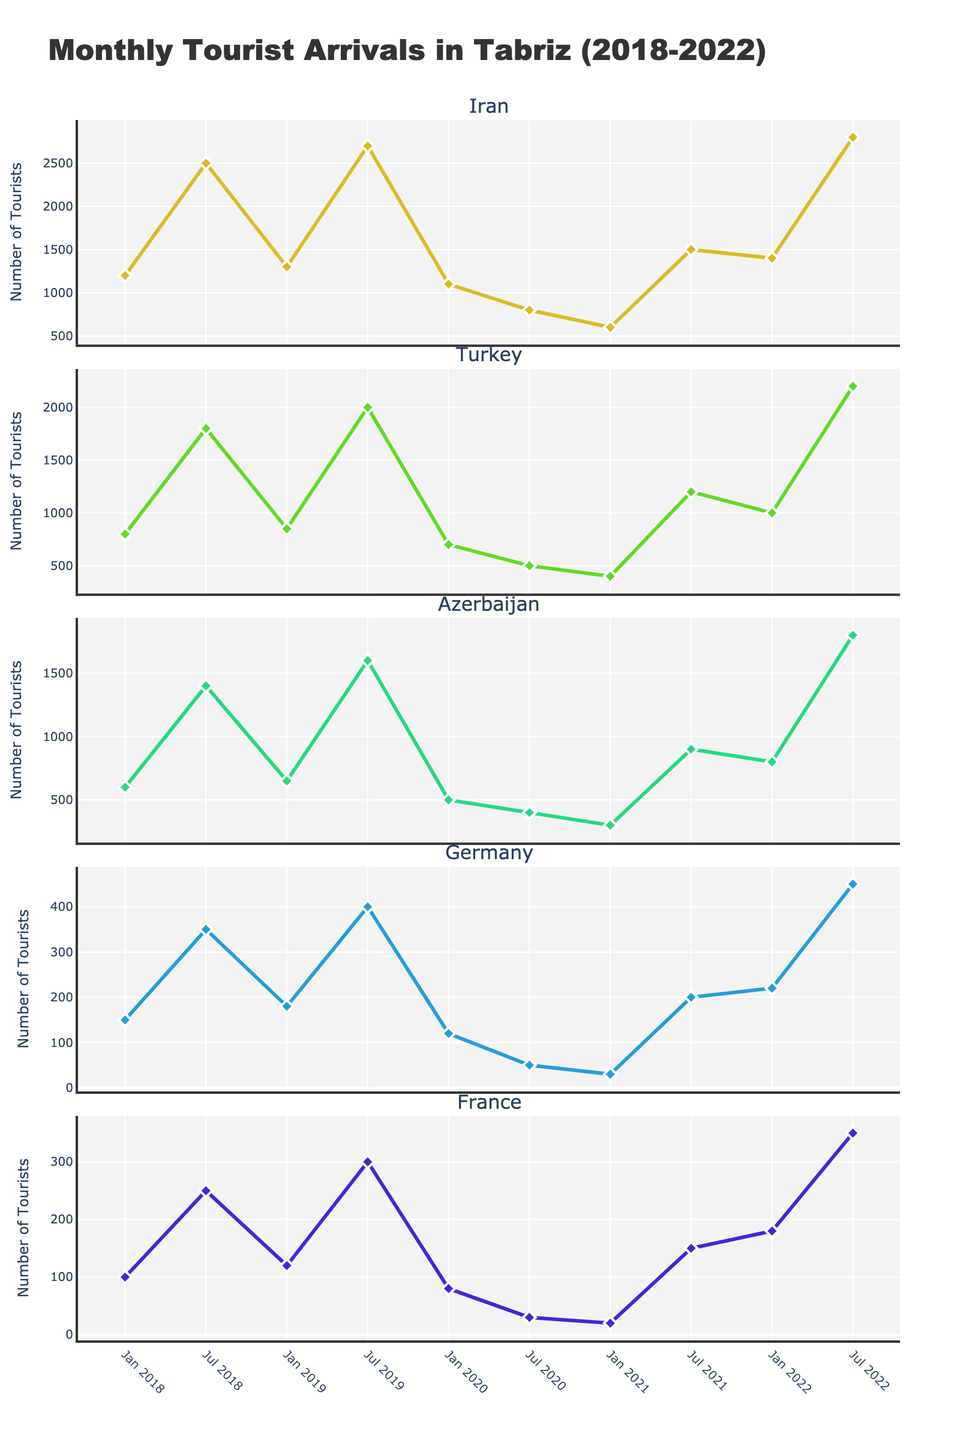How many tourists from Turkey visited Tabriz in January 2019? First, locate the subplot for Turkey. Then find the data point corresponding to January 2019. Observe the y-axis value at this point.
Answer: 850 What is the title of the figure? Look at the title text at the very top of the figure.
Answer: Monthly Tourist Arrivals in Tabriz (2018-2022) Which country saw the highest number of tourists visiting Tabriz in July 2022? Locate the data points for July 2022 across all subplots. Compare the y-axis values and identify the highest one.
Answer: Iran How did the number of tourists from France change from January 2021 to July 2021? Check the data points for France, specifically comparing the y-values at January 2021 and July 2021. Calculate the difference between them.
Answer: Increased by 130 Which months have data points that are plotted for five different years? Check the x-axis labels for each subplot to identify months that repeatedly occur across all years.
Answer: January and July What is the average number of tourists from Germany in January over the years presented? Find the data points for Germany in January for each year (2018, 2019, 2020, 2021, and 2022). Sum these values and divide by the number of years.
Answer: 134 Which country shows the steepest decrease in tourists from July 2019 to July 2020? Observe the slopes between July 2019 and July 2020 data points in all subplots. The steepest negative slope represents the steepest decrease.
Answer: Iran Did Azerbaijan have more tourists visiting Tabriz in January 2020 or January 2021? Compare the data point values for Azerbaijan in January 2020 and January 2021.
Answer: January 2020 What is the overall trend for tourists from Iran visiting Tabriz in July each year? Look at the data points for Iran in each July from 2018 to 2022 and observe the general direction (increasing, decreasing, or stable).
Answer: Increasing Which country had the least number of tourists in July 2020? Compare the y-values for all countries in July 2020 and identify the smallest one.
Answer: France 